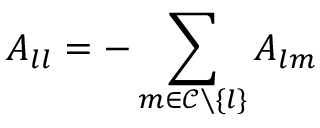<formula> <loc_0><loc_0><loc_500><loc_500>A _ { l l } = - \sum _ { m \in \mathcal { C } \ \{ l \} } A _ { l m }</formula> 